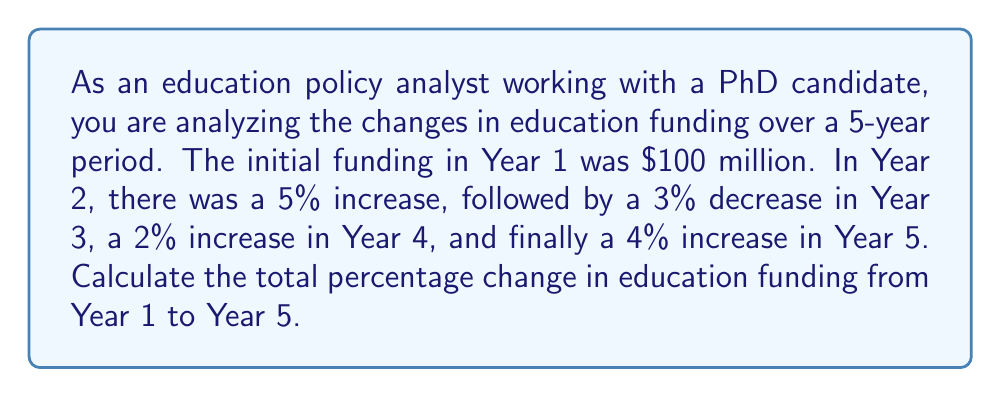Show me your answer to this math problem. To solve this problem, we'll follow these steps:

1. Calculate the funding for each year:

   Year 1: $100 million (initial)
   Year 2: $100 million × (1 + 0.05) = $105 million
   Year 3: $105 million × (1 - 0.03) = $101.85 million
   Year 4: $101.85 million × (1 + 0.02) = $103.887 million
   Year 5: $103.887 million × (1 + 0.04) = $108.04248 million

2. Calculate the total percentage change:

   $\text{Percentage change} = \frac{\text{Final value} - \text{Initial value}}{\text{Initial value}} \times 100\%$

   $$\text{Percentage change} = \frac{108.04248 - 100}{100} \times 100\%$$
   
   $$= \frac{8.04248}{100} \times 100\%$$
   
   $$= 0.0804248 \times 100\%$$
   
   $$= 8.04248\%$$

3. Round to two decimal places:
   
   $8.04\%$

Alternatively, we can calculate the total percentage change directly:

$$(1 + 0.05) \times (1 - 0.03) \times (1 + 0.02) \times (1 + 0.04) = 1.0804248$$

This gives us the same result: an 8.04248% increase.
Answer: The total percentage change in education funding from Year 1 to Year 5 is an increase of 8.04%. 